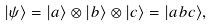Convert formula to latex. <formula><loc_0><loc_0><loc_500><loc_500>| \psi \rangle = | a \rangle \otimes | b \rangle \otimes | c \rangle = | a b c \rangle ,</formula> 